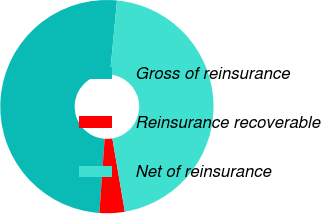<chart> <loc_0><loc_0><loc_500><loc_500><pie_chart><fcel>Gross of reinsurance<fcel>Reinsurance recoverable<fcel>Net of reinsurance<nl><fcel>50.38%<fcel>3.82%<fcel>45.8%<nl></chart> 